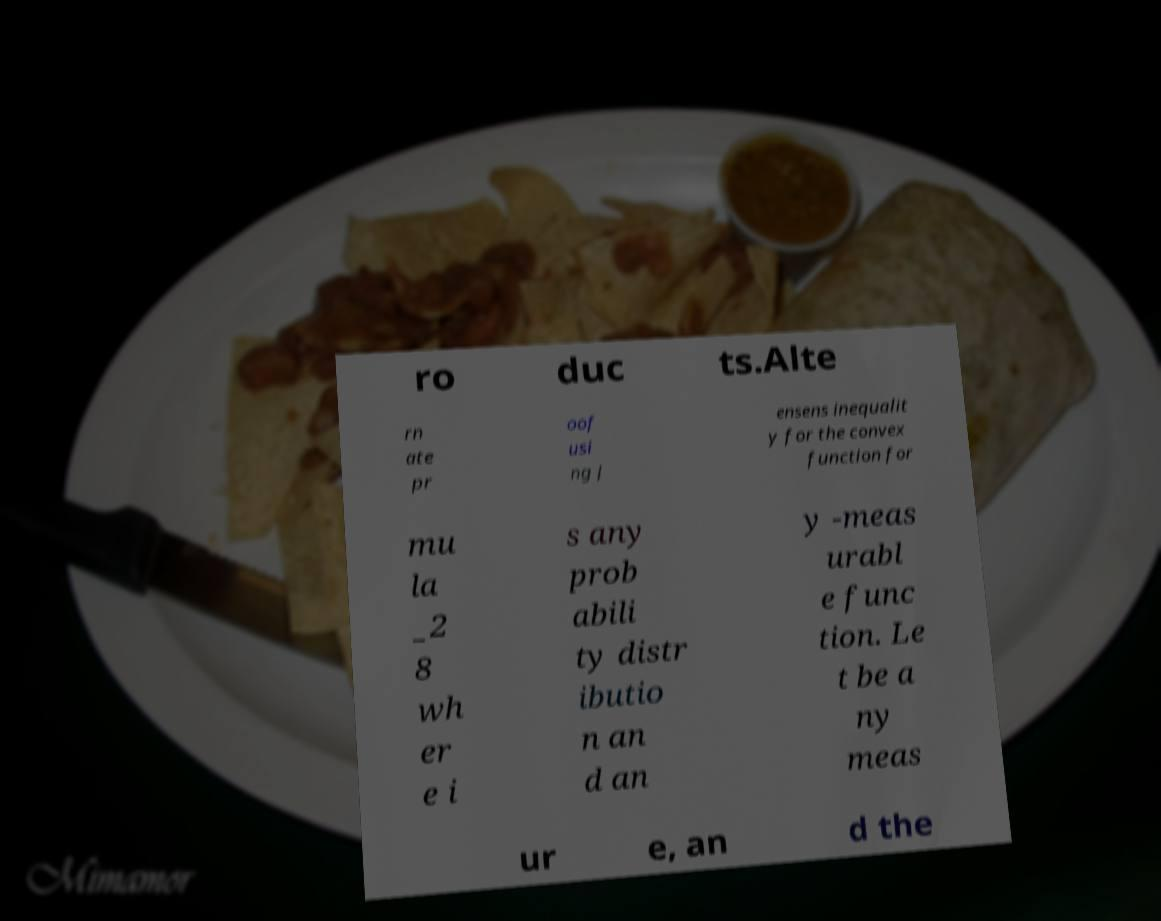Could you extract and type out the text from this image? ro duc ts.Alte rn ate pr oof usi ng J ensens inequalit y for the convex function for mu la _2 8 wh er e i s any prob abili ty distr ibutio n an d an y -meas urabl e func tion. Le t be a ny meas ur e, an d the 